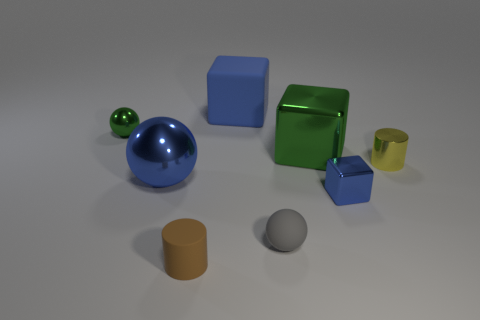The tiny cylinder that is behind the big sphere is what color?
Ensure brevity in your answer.  Yellow. There is a green object left of the matte cylinder; is there a blue object that is left of it?
Provide a short and direct response. No. Do the small yellow metallic thing and the blue object behind the large green thing have the same shape?
Provide a short and direct response. No. There is a object that is both to the right of the large green object and left of the yellow cylinder; what size is it?
Provide a succinct answer. Small. Is there a tiny sphere made of the same material as the small blue block?
Offer a terse response. Yes. There is a metallic object that is the same color as the small block; what size is it?
Ensure brevity in your answer.  Large. What is the material of the ball that is on the left side of the large blue shiny ball to the right of the small green sphere?
Your answer should be very brief. Metal. What number of tiny matte things have the same color as the matte cube?
Your answer should be compact. 0. What size is the green block that is made of the same material as the green ball?
Your answer should be very brief. Large. What shape is the large metallic object right of the small gray rubber thing?
Your answer should be very brief. Cube. 